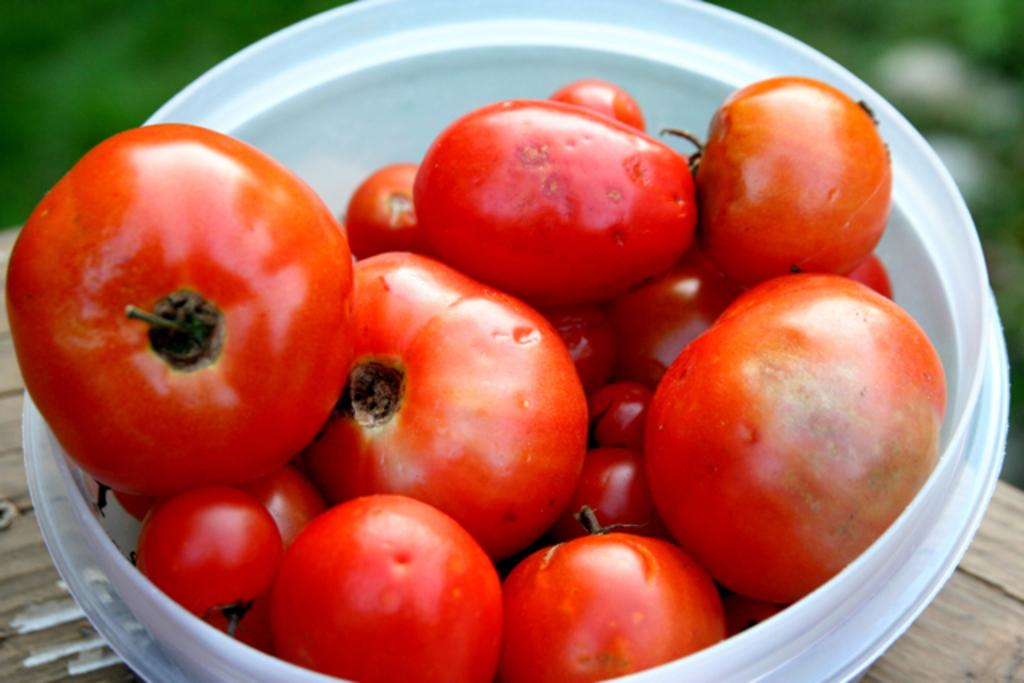What color is the bowl in the image? The bowl in the image is white. What is inside the white bowl? The bowl contains tomatoes. On what surface is the bowl placed? The bowl is placed on a wooden surface. What can be seen in the background of the image? The background of the image is blurred. What type of vegetation is visible in the image? There is greenery visible in the image. What type of unit is being measured in the image? There is no indication of any unit being measured in the image. What type of meal is being prepared in the image? There is no indication of any meal preparation in the image; it only shows a bowl of tomatoes on a wooden surface. 